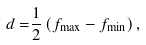Convert formula to latex. <formula><loc_0><loc_0><loc_500><loc_500>d = & \frac { 1 } { 2 } \left ( f _ { \max } - f _ { \min } \right ) ,</formula> 